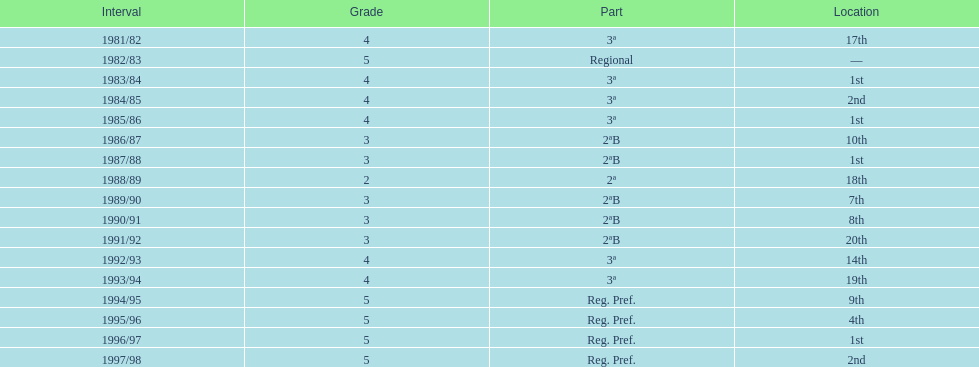How many years did they spend in tier 3? 5. 